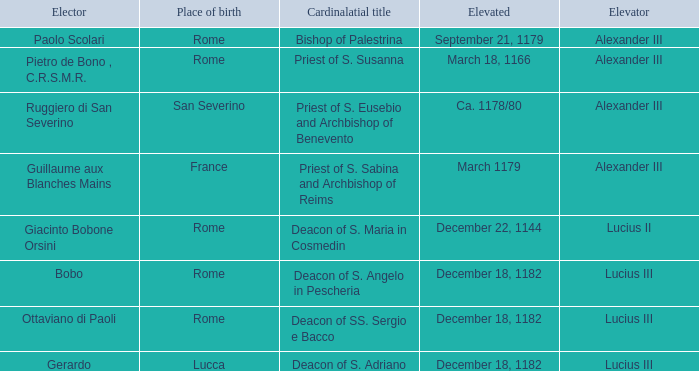Who is the Elector with a Cardinalatial title of Priest of S. Sabina and Archbishop of Reims? Guillaume aux Blanches Mains. 